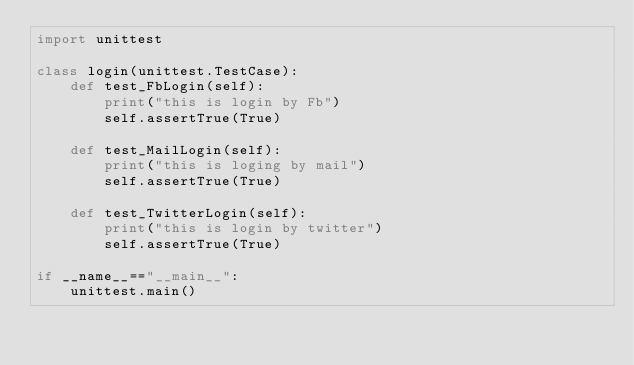Convert code to text. <code><loc_0><loc_0><loc_500><loc_500><_Python_>import unittest

class login(unittest.TestCase):
    def test_FbLogin(self):
        print("this is login by Fb")
        self.assertTrue(True)
    
    def test_MailLogin(self):
        print("this is loging by mail")
        self.assertTrue(True)

    def test_TwitterLogin(self):
        print("this is login by twitter")
        self.assertTrue(True)

if __name__=="__main__":
    unittest.main()</code> 